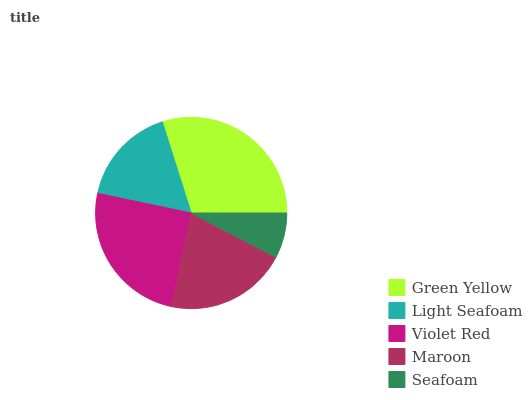Is Seafoam the minimum?
Answer yes or no. Yes. Is Green Yellow the maximum?
Answer yes or no. Yes. Is Light Seafoam the minimum?
Answer yes or no. No. Is Light Seafoam the maximum?
Answer yes or no. No. Is Green Yellow greater than Light Seafoam?
Answer yes or no. Yes. Is Light Seafoam less than Green Yellow?
Answer yes or no. Yes. Is Light Seafoam greater than Green Yellow?
Answer yes or no. No. Is Green Yellow less than Light Seafoam?
Answer yes or no. No. Is Maroon the high median?
Answer yes or no. Yes. Is Maroon the low median?
Answer yes or no. Yes. Is Light Seafoam the high median?
Answer yes or no. No. Is Violet Red the low median?
Answer yes or no. No. 